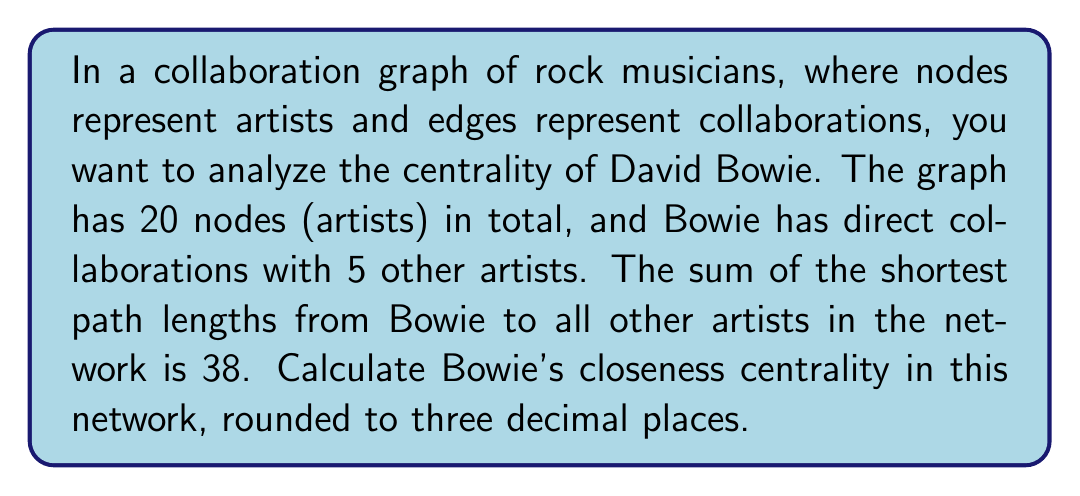Provide a solution to this math problem. To solve this problem, we'll use the concept of closeness centrality from graph theory. Closeness centrality measures how close a node is to all other nodes in the network. It's calculated as the reciprocal of the average shortest path length to all other nodes.

Let's break down the problem and solve it step-by-step:

1. We're given:
   - Total number of nodes (artists): $n = 20$
   - Number of Bowie's direct collaborations: 5 (not directly used in the calculation)
   - Sum of shortest path lengths from Bowie to all other artists: $\sum d(v,u) = 38$

2. The formula for closeness centrality is:

   $$C(v) = \frac{n - 1}{\sum_{u \neq v} d(v,u)}$$

   Where:
   - $C(v)$ is the closeness centrality of node $v$ (Bowie in this case)
   - $n$ is the total number of nodes in the network
   - $d(v,u)$ is the shortest path length from node $v$ to node $u$

3. Plugging in our values:

   $$C(\text{Bowie}) = \frac{20 - 1}{38} = \frac{19}{38}$$

4. Calculate the result:

   $$C(\text{Bowie}) = 0.5$$

5. Round to three decimal places:

   $$C(\text{Bowie}) \approx 0.500$$

This result indicates that David Bowie has a closeness centrality of 0.500 in this collaboration network, suggesting he has relatively close connections to other artists in the network.
Answer: $0.500$ 